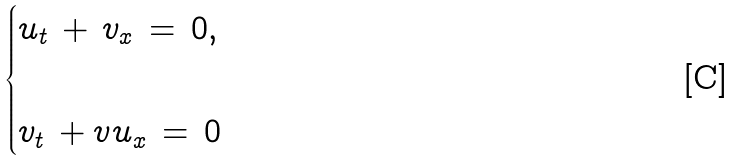Convert formula to latex. <formula><loc_0><loc_0><loc_500><loc_500>\begin{cases} u _ { t } \, + \, v _ { x } \, = \, 0 , \\ \\ v _ { t } \, + v u _ { x } \, = \, 0 \end{cases}</formula> 